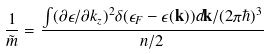Convert formula to latex. <formula><loc_0><loc_0><loc_500><loc_500>\frac { 1 } { \tilde { m } } = \frac { \int ( \partial \epsilon / \partial k _ { z } ) ^ { 2 } \delta ( \epsilon _ { F } - \epsilon ( \mathbf k ) ) d \mathbf k / ( 2 \pi \hbar { ) } ^ { 3 } } { n / 2 }</formula> 